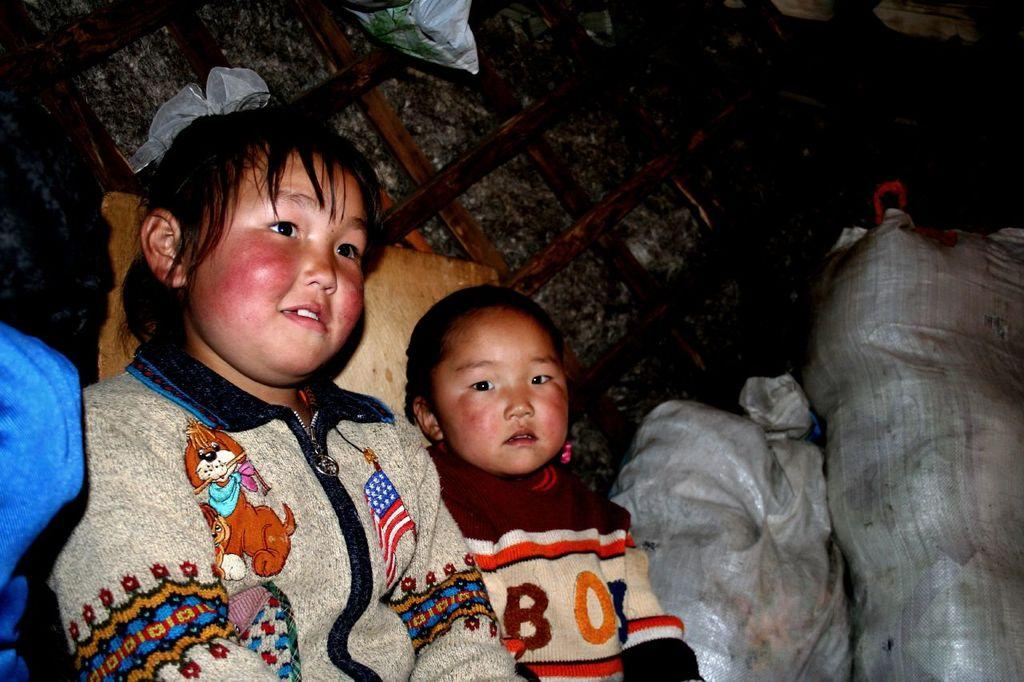What is the main subject in the foreground of the image? There are girls sitting in the foreground of the image. Where are the girls sitting? The girls are sitting under a hut. What type of objects can be seen in the image? There are gunny bags and a wooden plank-like object visible in the image. What type of music can be heard coming from the vase in the image? There is no vase present in the image, and therefore no music can be heard coming from it. 